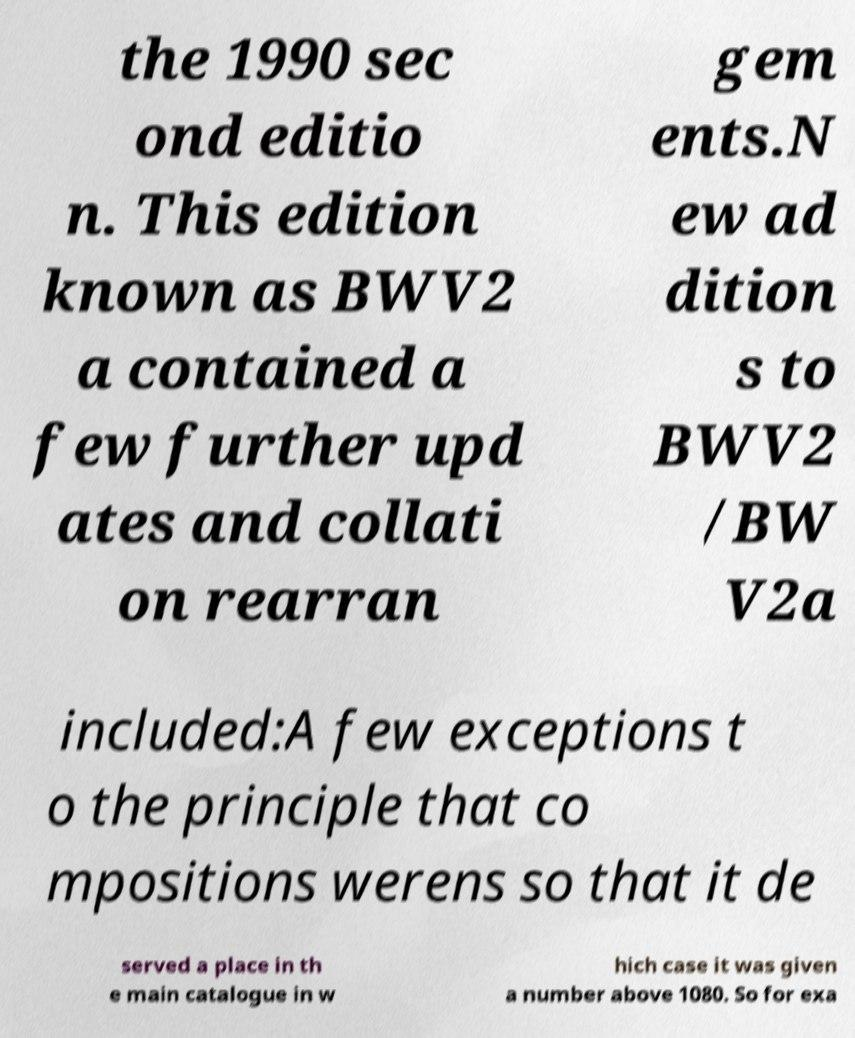Can you accurately transcribe the text from the provided image for me? the 1990 sec ond editio n. This edition known as BWV2 a contained a few further upd ates and collati on rearran gem ents.N ew ad dition s to BWV2 /BW V2a included:A few exceptions t o the principle that co mpositions werens so that it de served a place in th e main catalogue in w hich case it was given a number above 1080. So for exa 